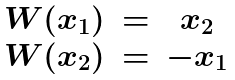Convert formula to latex. <formula><loc_0><loc_0><loc_500><loc_500>\begin{matrix} W ( x _ { 1 } ) & = & x _ { 2 } \\ W ( x _ { 2 } ) & = & - x _ { 1 } \end{matrix}</formula> 